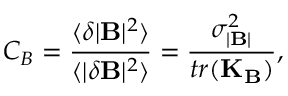<formula> <loc_0><loc_0><loc_500><loc_500>C _ { B } = \frac { \langle \delta | B | ^ { 2 } \rangle } { \langle | \delta B | ^ { 2 } \rangle } = \frac { \sigma _ { | B | } ^ { 2 } } { t r ( K _ { B } ) } ,</formula> 